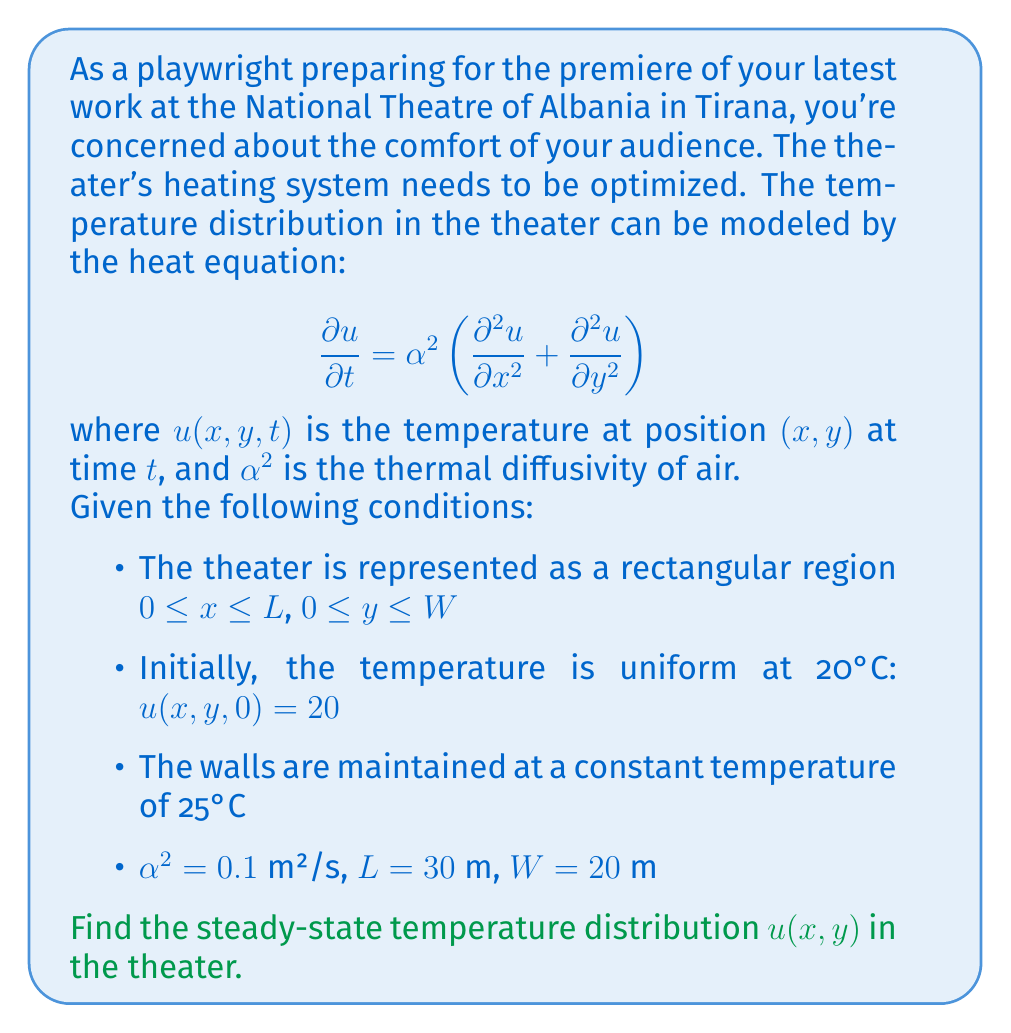Teach me how to tackle this problem. To solve this problem, we need to follow these steps:

1) For the steady-state solution, the temperature doesn't change with time, so $\frac{\partial u}{\partial t} = 0$. The heat equation reduces to:

   $$\frac{\partial^2 u}{\partial x^2} + \frac{\partial^2 u}{\partial y^2} = 0$$

   This is Laplace's equation in two dimensions.

2) The boundary conditions are:
   
   $u(0,y) = u(L,y) = u(x,0) = u(x,W) = 25$

3) The solution to this problem can be found using separation of variables. We assume a solution of the form:

   $$u(x,y) = X(x)Y(y)$$

4) Substituting this into Laplace's equation:

   $$X''(x)Y(y) + X(x)Y''(y) = 0$$

   $$\frac{X''(x)}{X(x)} = -\frac{Y''(y)}{Y(y)} = -\lambda^2$$

5) This gives us two ordinary differential equations:

   $$X''(x) + \lambda^2 X(x) = 0$$
   $$Y''(y) + \lambda^2 Y(y) = 0$$

6) The general solutions are:

   $$X(x) = A \cos(\lambda x) + B \sin(\lambda x)$$
   $$Y(y) = C \cos(\lambda y) + D \sin(\lambda y)$$

7) Applying the boundary conditions, we find that the solution has the form:

   $$u(x,y) = 25 + \sum_{m=1}^{\infty} \sum_{n=1}^{\infty} A_{mn} \sin(\frac{m\pi x}{L}) \sin(\frac{n\pi y}{W})$$

8) The coefficients $A_{mn}$ are found using Fourier series:

   $$A_{mn} = \frac{4}{LW} \int_0^L \int_0^W (20 - 25) \sin(\frac{m\pi x}{L}) \sin(\frac{n\pi y}{W}) dx dy$$

9) Evaluating this integral:

   $$A_{mn} = -\frac{16}{mn\pi^2} (1 - (-1)^m)(1 - (-1)^n)$$

Therefore, the steady-state temperature distribution is given by:

$$u(x,y) = 25 - \sum_{m=1,3,5,...}^{\infty} \sum_{n=1,3,5,...}^{\infty} \frac{64}{mn\pi^2} \sin(\frac{m\pi x}{30}) \sin(\frac{n\pi y}{20})$$
Answer: The steady-state temperature distribution in the theater is:

$$u(x,y) = 25 - \sum_{m=1,3,5,...}^{\infty} \sum_{n=1,3,5,...}^{\infty} \frac{64}{mn\pi^2} \sin(\frac{m\pi x}{30}) \sin(\frac{n\pi y}{20})$$

where $x$ and $y$ are the coordinates in meters, with $0 \leq x \leq 30$ and $0 \leq y \leq 20$. 